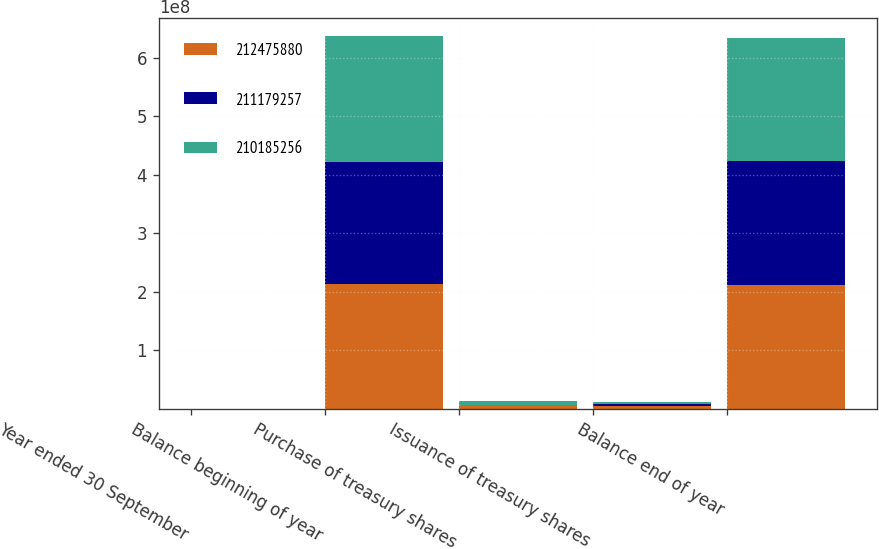Convert chart. <chart><loc_0><loc_0><loc_500><loc_500><stacked_bar_chart><ecel><fcel>Year ended 30 September<fcel>Balance beginning of year<fcel>Purchase of treasury shares<fcel>Issuance of treasury shares<fcel>Balance end of year<nl><fcel>2.12476e+08<fcel>2013<fcel>2.12476e+08<fcel>5.72102e+06<fcel>4.42439e+06<fcel>2.11179e+08<nl><fcel>2.11179e+08<fcel>2012<fcel>2.10185e+08<fcel>594916<fcel>2.88554e+06<fcel>2.12476e+08<nl><fcel>2.10185e+08<fcel>2011<fcel>2.13803e+08<fcel>7.43361e+06<fcel>3.816e+06<fcel>2.10185e+08<nl></chart> 